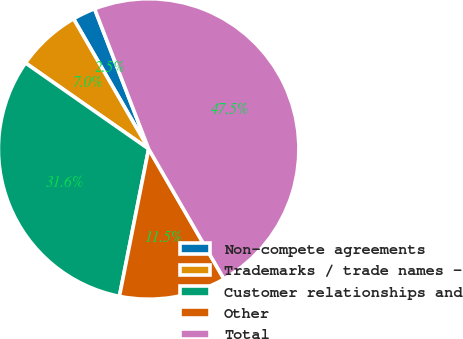Convert chart to OTSL. <chart><loc_0><loc_0><loc_500><loc_500><pie_chart><fcel>Non-compete agreements<fcel>Trademarks / trade names -<fcel>Customer relationships and<fcel>Other<fcel>Total<nl><fcel>2.47%<fcel>6.97%<fcel>31.58%<fcel>11.47%<fcel>47.5%<nl></chart> 